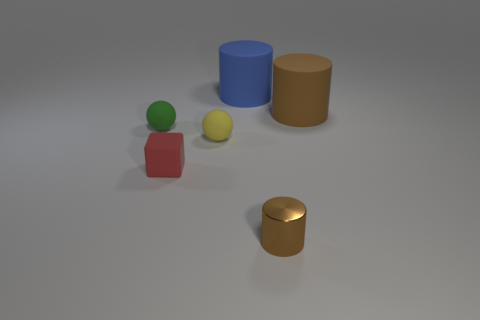Can you guess the material the objects might be made of based on their appearance? Based on their appearance, the small green ball and the red cube appear to be made of a matte plastic material, the yellow sphere might be of a rubber material due to its slightly dull texture, while the blue and brown cylinders seem to have a glossy, possibly metallic finish. The golden cylinder, with its distinct sheen, suggests it could be made of a polished metal, perhaps brass or gold in color. 